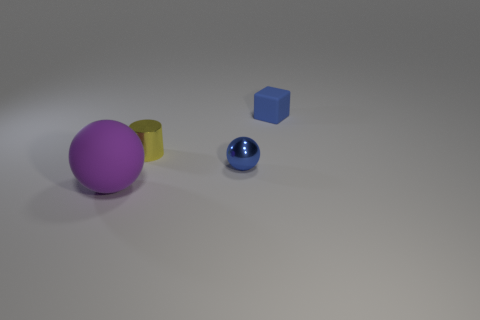There is a metallic cylinder that is the same size as the blue sphere; what is its color?
Keep it short and to the point. Yellow. What number of small shiny objects are the same shape as the big purple thing?
Your answer should be compact. 1. What is the color of the sphere to the left of the small blue shiny sphere?
Your answer should be very brief. Purple. What number of metallic things are yellow things or cubes?
Keep it short and to the point. 1. What is the shape of the tiny object that is the same color as the small matte cube?
Give a very brief answer. Sphere. What number of blue shiny things are the same size as the blue matte thing?
Offer a terse response. 1. There is a thing that is both on the left side of the tiny blue ball and in front of the tiny yellow metal cylinder; what is its color?
Ensure brevity in your answer.  Purple. How many objects are purple spheres or tiny matte things?
Ensure brevity in your answer.  2. How many tiny objects are balls or yellow metallic things?
Your answer should be very brief. 2. Is there any other thing that is the same color as the cylinder?
Give a very brief answer. No. 